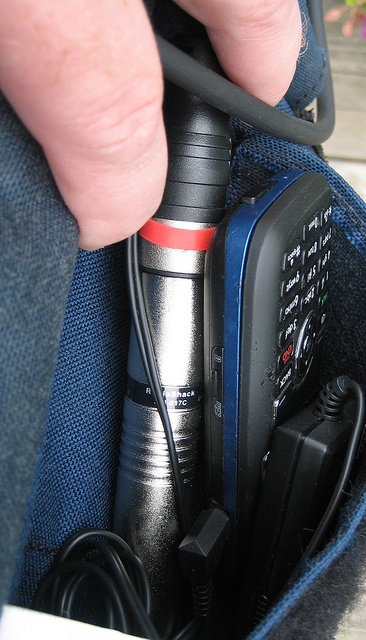Describe the objects in this image and their specific colors. I can see people in lightpink, pink, and gray tones and cell phone in lightpink, black, gray, navy, and darkblue tones in this image. 